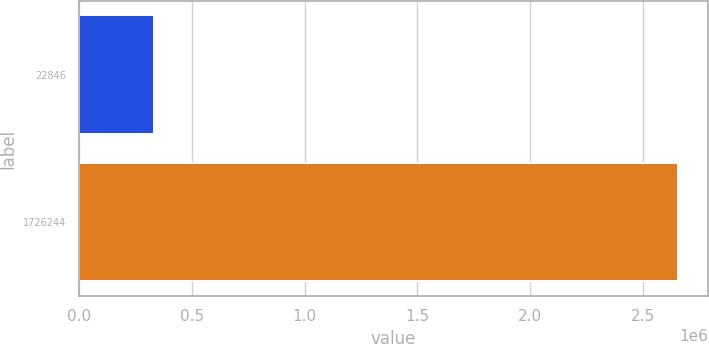Convert chart to OTSL. <chart><loc_0><loc_0><loc_500><loc_500><bar_chart><fcel>22846<fcel>1726244<nl><fcel>329944<fcel>2.65734e+06<nl></chart> 